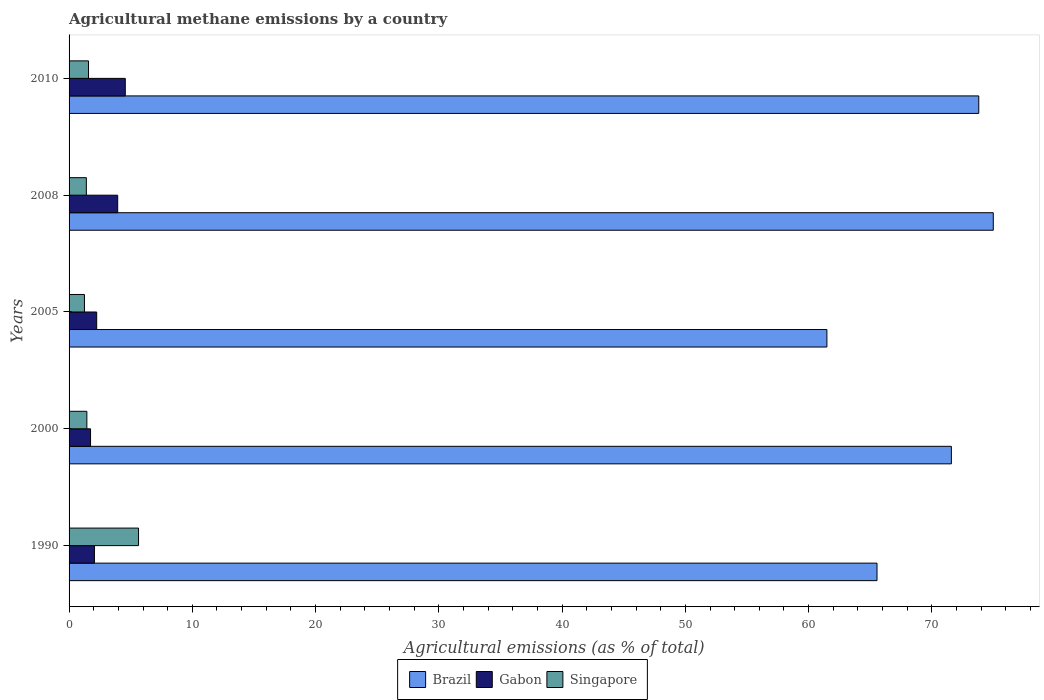How many different coloured bars are there?
Offer a terse response. 3. Are the number of bars per tick equal to the number of legend labels?
Ensure brevity in your answer.  Yes. Are the number of bars on each tick of the Y-axis equal?
Give a very brief answer. Yes. How many bars are there on the 1st tick from the top?
Ensure brevity in your answer.  3. What is the label of the 5th group of bars from the top?
Your answer should be very brief. 1990. What is the amount of agricultural methane emitted in Gabon in 2005?
Offer a very short reply. 2.24. Across all years, what is the maximum amount of agricultural methane emitted in Singapore?
Offer a terse response. 5.63. Across all years, what is the minimum amount of agricultural methane emitted in Brazil?
Make the answer very short. 61.48. In which year was the amount of agricultural methane emitted in Brazil maximum?
Keep it short and to the point. 2008. What is the total amount of agricultural methane emitted in Gabon in the graph?
Offer a terse response. 14.55. What is the difference between the amount of agricultural methane emitted in Gabon in 2008 and that in 2010?
Make the answer very short. -0.62. What is the difference between the amount of agricultural methane emitted in Gabon in 2010 and the amount of agricultural methane emitted in Brazil in 2005?
Your answer should be compact. -56.92. What is the average amount of agricultural methane emitted in Singapore per year?
Offer a very short reply. 2.26. In the year 2010, what is the difference between the amount of agricultural methane emitted in Brazil and amount of agricultural methane emitted in Gabon?
Offer a terse response. 69.24. What is the ratio of the amount of agricultural methane emitted in Brazil in 2008 to that in 2010?
Make the answer very short. 1.02. Is the amount of agricultural methane emitted in Gabon in 2005 less than that in 2008?
Your answer should be very brief. Yes. What is the difference between the highest and the second highest amount of agricultural methane emitted in Singapore?
Offer a very short reply. 4.06. What is the difference between the highest and the lowest amount of agricultural methane emitted in Brazil?
Your answer should be compact. 13.5. Is the sum of the amount of agricultural methane emitted in Singapore in 1990 and 2008 greater than the maximum amount of agricultural methane emitted in Gabon across all years?
Give a very brief answer. Yes. What does the 2nd bar from the top in 2010 represents?
Give a very brief answer. Gabon. Is it the case that in every year, the sum of the amount of agricultural methane emitted in Brazil and amount of agricultural methane emitted in Singapore is greater than the amount of agricultural methane emitted in Gabon?
Your answer should be very brief. Yes. What is the difference between two consecutive major ticks on the X-axis?
Offer a very short reply. 10. Are the values on the major ticks of X-axis written in scientific E-notation?
Keep it short and to the point. No. How many legend labels are there?
Provide a succinct answer. 3. What is the title of the graph?
Make the answer very short. Agricultural methane emissions by a country. Does "Upper middle income" appear as one of the legend labels in the graph?
Offer a very short reply. No. What is the label or title of the X-axis?
Offer a terse response. Agricultural emissions (as % of total). What is the label or title of the Y-axis?
Offer a very short reply. Years. What is the Agricultural emissions (as % of total) in Brazil in 1990?
Provide a succinct answer. 65.55. What is the Agricultural emissions (as % of total) of Gabon in 1990?
Offer a very short reply. 2.06. What is the Agricultural emissions (as % of total) of Singapore in 1990?
Provide a short and direct response. 5.63. What is the Agricultural emissions (as % of total) in Brazil in 2000?
Ensure brevity in your answer.  71.58. What is the Agricultural emissions (as % of total) in Gabon in 2000?
Offer a terse response. 1.74. What is the Agricultural emissions (as % of total) in Singapore in 2000?
Provide a short and direct response. 1.44. What is the Agricultural emissions (as % of total) in Brazil in 2005?
Provide a short and direct response. 61.48. What is the Agricultural emissions (as % of total) in Gabon in 2005?
Provide a succinct answer. 2.24. What is the Agricultural emissions (as % of total) of Singapore in 2005?
Make the answer very short. 1.25. What is the Agricultural emissions (as % of total) of Brazil in 2008?
Your answer should be very brief. 74.98. What is the Agricultural emissions (as % of total) of Gabon in 2008?
Your answer should be very brief. 3.94. What is the Agricultural emissions (as % of total) in Singapore in 2008?
Your answer should be very brief. 1.4. What is the Agricultural emissions (as % of total) of Brazil in 2010?
Offer a very short reply. 73.8. What is the Agricultural emissions (as % of total) of Gabon in 2010?
Ensure brevity in your answer.  4.56. What is the Agricultural emissions (as % of total) in Singapore in 2010?
Make the answer very short. 1.58. Across all years, what is the maximum Agricultural emissions (as % of total) in Brazil?
Provide a succinct answer. 74.98. Across all years, what is the maximum Agricultural emissions (as % of total) of Gabon?
Offer a very short reply. 4.56. Across all years, what is the maximum Agricultural emissions (as % of total) of Singapore?
Provide a succinct answer. 5.63. Across all years, what is the minimum Agricultural emissions (as % of total) in Brazil?
Offer a terse response. 61.48. Across all years, what is the minimum Agricultural emissions (as % of total) of Gabon?
Keep it short and to the point. 1.74. Across all years, what is the minimum Agricultural emissions (as % of total) in Singapore?
Your answer should be compact. 1.25. What is the total Agricultural emissions (as % of total) in Brazil in the graph?
Your answer should be very brief. 347.4. What is the total Agricultural emissions (as % of total) of Gabon in the graph?
Your answer should be compact. 14.55. What is the total Agricultural emissions (as % of total) in Singapore in the graph?
Offer a very short reply. 11.3. What is the difference between the Agricultural emissions (as % of total) of Brazil in 1990 and that in 2000?
Your response must be concise. -6.03. What is the difference between the Agricultural emissions (as % of total) of Gabon in 1990 and that in 2000?
Provide a succinct answer. 0.32. What is the difference between the Agricultural emissions (as % of total) in Singapore in 1990 and that in 2000?
Make the answer very short. 4.19. What is the difference between the Agricultural emissions (as % of total) in Brazil in 1990 and that in 2005?
Keep it short and to the point. 4.07. What is the difference between the Agricultural emissions (as % of total) of Gabon in 1990 and that in 2005?
Give a very brief answer. -0.18. What is the difference between the Agricultural emissions (as % of total) of Singapore in 1990 and that in 2005?
Provide a short and direct response. 4.39. What is the difference between the Agricultural emissions (as % of total) of Brazil in 1990 and that in 2008?
Your answer should be compact. -9.43. What is the difference between the Agricultural emissions (as % of total) in Gabon in 1990 and that in 2008?
Your answer should be compact. -1.89. What is the difference between the Agricultural emissions (as % of total) in Singapore in 1990 and that in 2008?
Provide a short and direct response. 4.23. What is the difference between the Agricultural emissions (as % of total) in Brazil in 1990 and that in 2010?
Give a very brief answer. -8.25. What is the difference between the Agricultural emissions (as % of total) of Gabon in 1990 and that in 2010?
Give a very brief answer. -2.5. What is the difference between the Agricultural emissions (as % of total) in Singapore in 1990 and that in 2010?
Your response must be concise. 4.06. What is the difference between the Agricultural emissions (as % of total) in Brazil in 2000 and that in 2005?
Offer a very short reply. 10.1. What is the difference between the Agricultural emissions (as % of total) of Gabon in 2000 and that in 2005?
Provide a succinct answer. -0.5. What is the difference between the Agricultural emissions (as % of total) in Singapore in 2000 and that in 2005?
Make the answer very short. 0.2. What is the difference between the Agricultural emissions (as % of total) in Brazil in 2000 and that in 2008?
Offer a very short reply. -3.4. What is the difference between the Agricultural emissions (as % of total) of Gabon in 2000 and that in 2008?
Ensure brevity in your answer.  -2.2. What is the difference between the Agricultural emissions (as % of total) of Singapore in 2000 and that in 2008?
Offer a very short reply. 0.04. What is the difference between the Agricultural emissions (as % of total) of Brazil in 2000 and that in 2010?
Keep it short and to the point. -2.22. What is the difference between the Agricultural emissions (as % of total) in Gabon in 2000 and that in 2010?
Your answer should be very brief. -2.82. What is the difference between the Agricultural emissions (as % of total) in Singapore in 2000 and that in 2010?
Make the answer very short. -0.13. What is the difference between the Agricultural emissions (as % of total) in Brazil in 2005 and that in 2008?
Make the answer very short. -13.5. What is the difference between the Agricultural emissions (as % of total) of Gabon in 2005 and that in 2008?
Offer a very short reply. -1.7. What is the difference between the Agricultural emissions (as % of total) of Singapore in 2005 and that in 2008?
Make the answer very short. -0.15. What is the difference between the Agricultural emissions (as % of total) in Brazil in 2005 and that in 2010?
Offer a terse response. -12.32. What is the difference between the Agricultural emissions (as % of total) in Gabon in 2005 and that in 2010?
Provide a succinct answer. -2.32. What is the difference between the Agricultural emissions (as % of total) of Singapore in 2005 and that in 2010?
Keep it short and to the point. -0.33. What is the difference between the Agricultural emissions (as % of total) of Brazil in 2008 and that in 2010?
Your answer should be compact. 1.18. What is the difference between the Agricultural emissions (as % of total) in Gabon in 2008 and that in 2010?
Give a very brief answer. -0.62. What is the difference between the Agricultural emissions (as % of total) in Singapore in 2008 and that in 2010?
Ensure brevity in your answer.  -0.18. What is the difference between the Agricultural emissions (as % of total) of Brazil in 1990 and the Agricultural emissions (as % of total) of Gabon in 2000?
Give a very brief answer. 63.81. What is the difference between the Agricultural emissions (as % of total) of Brazil in 1990 and the Agricultural emissions (as % of total) of Singapore in 2000?
Offer a terse response. 64.11. What is the difference between the Agricultural emissions (as % of total) of Gabon in 1990 and the Agricultural emissions (as % of total) of Singapore in 2000?
Offer a terse response. 0.62. What is the difference between the Agricultural emissions (as % of total) in Brazil in 1990 and the Agricultural emissions (as % of total) in Gabon in 2005?
Make the answer very short. 63.31. What is the difference between the Agricultural emissions (as % of total) in Brazil in 1990 and the Agricultural emissions (as % of total) in Singapore in 2005?
Offer a very short reply. 64.3. What is the difference between the Agricultural emissions (as % of total) in Gabon in 1990 and the Agricultural emissions (as % of total) in Singapore in 2005?
Make the answer very short. 0.81. What is the difference between the Agricultural emissions (as % of total) in Brazil in 1990 and the Agricultural emissions (as % of total) in Gabon in 2008?
Offer a very short reply. 61.61. What is the difference between the Agricultural emissions (as % of total) in Brazil in 1990 and the Agricultural emissions (as % of total) in Singapore in 2008?
Your answer should be compact. 64.15. What is the difference between the Agricultural emissions (as % of total) in Gabon in 1990 and the Agricultural emissions (as % of total) in Singapore in 2008?
Provide a succinct answer. 0.66. What is the difference between the Agricultural emissions (as % of total) of Brazil in 1990 and the Agricultural emissions (as % of total) of Gabon in 2010?
Keep it short and to the point. 60.99. What is the difference between the Agricultural emissions (as % of total) in Brazil in 1990 and the Agricultural emissions (as % of total) in Singapore in 2010?
Provide a succinct answer. 63.97. What is the difference between the Agricultural emissions (as % of total) of Gabon in 1990 and the Agricultural emissions (as % of total) of Singapore in 2010?
Your answer should be compact. 0.48. What is the difference between the Agricultural emissions (as % of total) of Brazil in 2000 and the Agricultural emissions (as % of total) of Gabon in 2005?
Give a very brief answer. 69.34. What is the difference between the Agricultural emissions (as % of total) of Brazil in 2000 and the Agricultural emissions (as % of total) of Singapore in 2005?
Your response must be concise. 70.33. What is the difference between the Agricultural emissions (as % of total) of Gabon in 2000 and the Agricultural emissions (as % of total) of Singapore in 2005?
Ensure brevity in your answer.  0.49. What is the difference between the Agricultural emissions (as % of total) in Brazil in 2000 and the Agricultural emissions (as % of total) in Gabon in 2008?
Offer a very short reply. 67.64. What is the difference between the Agricultural emissions (as % of total) in Brazil in 2000 and the Agricultural emissions (as % of total) in Singapore in 2008?
Provide a succinct answer. 70.18. What is the difference between the Agricultural emissions (as % of total) in Gabon in 2000 and the Agricultural emissions (as % of total) in Singapore in 2008?
Your answer should be very brief. 0.34. What is the difference between the Agricultural emissions (as % of total) of Brazil in 2000 and the Agricultural emissions (as % of total) of Gabon in 2010?
Offer a terse response. 67.02. What is the difference between the Agricultural emissions (as % of total) in Brazil in 2000 and the Agricultural emissions (as % of total) in Singapore in 2010?
Keep it short and to the point. 70. What is the difference between the Agricultural emissions (as % of total) of Gabon in 2000 and the Agricultural emissions (as % of total) of Singapore in 2010?
Your answer should be compact. 0.16. What is the difference between the Agricultural emissions (as % of total) of Brazil in 2005 and the Agricultural emissions (as % of total) of Gabon in 2008?
Provide a succinct answer. 57.54. What is the difference between the Agricultural emissions (as % of total) in Brazil in 2005 and the Agricultural emissions (as % of total) in Singapore in 2008?
Your answer should be very brief. 60.08. What is the difference between the Agricultural emissions (as % of total) in Gabon in 2005 and the Agricultural emissions (as % of total) in Singapore in 2008?
Provide a succinct answer. 0.84. What is the difference between the Agricultural emissions (as % of total) in Brazil in 2005 and the Agricultural emissions (as % of total) in Gabon in 2010?
Offer a terse response. 56.92. What is the difference between the Agricultural emissions (as % of total) in Brazil in 2005 and the Agricultural emissions (as % of total) in Singapore in 2010?
Offer a very short reply. 59.91. What is the difference between the Agricultural emissions (as % of total) of Gabon in 2005 and the Agricultural emissions (as % of total) of Singapore in 2010?
Provide a short and direct response. 0.66. What is the difference between the Agricultural emissions (as % of total) in Brazil in 2008 and the Agricultural emissions (as % of total) in Gabon in 2010?
Your answer should be compact. 70.42. What is the difference between the Agricultural emissions (as % of total) of Brazil in 2008 and the Agricultural emissions (as % of total) of Singapore in 2010?
Ensure brevity in your answer.  73.4. What is the difference between the Agricultural emissions (as % of total) in Gabon in 2008 and the Agricultural emissions (as % of total) in Singapore in 2010?
Give a very brief answer. 2.37. What is the average Agricultural emissions (as % of total) in Brazil per year?
Your response must be concise. 69.48. What is the average Agricultural emissions (as % of total) of Gabon per year?
Keep it short and to the point. 2.91. What is the average Agricultural emissions (as % of total) in Singapore per year?
Make the answer very short. 2.26. In the year 1990, what is the difference between the Agricultural emissions (as % of total) of Brazil and Agricultural emissions (as % of total) of Gabon?
Your answer should be very brief. 63.49. In the year 1990, what is the difference between the Agricultural emissions (as % of total) of Brazil and Agricultural emissions (as % of total) of Singapore?
Make the answer very short. 59.91. In the year 1990, what is the difference between the Agricultural emissions (as % of total) in Gabon and Agricultural emissions (as % of total) in Singapore?
Keep it short and to the point. -3.58. In the year 2000, what is the difference between the Agricultural emissions (as % of total) in Brazil and Agricultural emissions (as % of total) in Gabon?
Offer a very short reply. 69.84. In the year 2000, what is the difference between the Agricultural emissions (as % of total) in Brazil and Agricultural emissions (as % of total) in Singapore?
Give a very brief answer. 70.14. In the year 2000, what is the difference between the Agricultural emissions (as % of total) in Gabon and Agricultural emissions (as % of total) in Singapore?
Your answer should be very brief. 0.3. In the year 2005, what is the difference between the Agricultural emissions (as % of total) in Brazil and Agricultural emissions (as % of total) in Gabon?
Your response must be concise. 59.24. In the year 2005, what is the difference between the Agricultural emissions (as % of total) in Brazil and Agricultural emissions (as % of total) in Singapore?
Ensure brevity in your answer.  60.24. In the year 2005, what is the difference between the Agricultural emissions (as % of total) of Gabon and Agricultural emissions (as % of total) of Singapore?
Make the answer very short. 0.99. In the year 2008, what is the difference between the Agricultural emissions (as % of total) of Brazil and Agricultural emissions (as % of total) of Gabon?
Your response must be concise. 71.04. In the year 2008, what is the difference between the Agricultural emissions (as % of total) in Brazil and Agricultural emissions (as % of total) in Singapore?
Provide a short and direct response. 73.58. In the year 2008, what is the difference between the Agricultural emissions (as % of total) of Gabon and Agricultural emissions (as % of total) of Singapore?
Keep it short and to the point. 2.54. In the year 2010, what is the difference between the Agricultural emissions (as % of total) in Brazil and Agricultural emissions (as % of total) in Gabon?
Offer a terse response. 69.24. In the year 2010, what is the difference between the Agricultural emissions (as % of total) of Brazil and Agricultural emissions (as % of total) of Singapore?
Ensure brevity in your answer.  72.23. In the year 2010, what is the difference between the Agricultural emissions (as % of total) of Gabon and Agricultural emissions (as % of total) of Singapore?
Ensure brevity in your answer.  2.98. What is the ratio of the Agricultural emissions (as % of total) in Brazil in 1990 to that in 2000?
Make the answer very short. 0.92. What is the ratio of the Agricultural emissions (as % of total) in Gabon in 1990 to that in 2000?
Offer a very short reply. 1.18. What is the ratio of the Agricultural emissions (as % of total) of Singapore in 1990 to that in 2000?
Ensure brevity in your answer.  3.9. What is the ratio of the Agricultural emissions (as % of total) in Brazil in 1990 to that in 2005?
Offer a terse response. 1.07. What is the ratio of the Agricultural emissions (as % of total) of Gabon in 1990 to that in 2005?
Offer a very short reply. 0.92. What is the ratio of the Agricultural emissions (as % of total) of Singapore in 1990 to that in 2005?
Your answer should be very brief. 4.52. What is the ratio of the Agricultural emissions (as % of total) of Brazil in 1990 to that in 2008?
Your response must be concise. 0.87. What is the ratio of the Agricultural emissions (as % of total) in Gabon in 1990 to that in 2008?
Provide a succinct answer. 0.52. What is the ratio of the Agricultural emissions (as % of total) of Singapore in 1990 to that in 2008?
Ensure brevity in your answer.  4.02. What is the ratio of the Agricultural emissions (as % of total) in Brazil in 1990 to that in 2010?
Make the answer very short. 0.89. What is the ratio of the Agricultural emissions (as % of total) of Gabon in 1990 to that in 2010?
Your response must be concise. 0.45. What is the ratio of the Agricultural emissions (as % of total) in Singapore in 1990 to that in 2010?
Your answer should be compact. 3.57. What is the ratio of the Agricultural emissions (as % of total) in Brazil in 2000 to that in 2005?
Provide a succinct answer. 1.16. What is the ratio of the Agricultural emissions (as % of total) of Gabon in 2000 to that in 2005?
Keep it short and to the point. 0.78. What is the ratio of the Agricultural emissions (as % of total) in Singapore in 2000 to that in 2005?
Your response must be concise. 1.16. What is the ratio of the Agricultural emissions (as % of total) in Brazil in 2000 to that in 2008?
Provide a short and direct response. 0.95. What is the ratio of the Agricultural emissions (as % of total) in Gabon in 2000 to that in 2008?
Make the answer very short. 0.44. What is the ratio of the Agricultural emissions (as % of total) of Singapore in 2000 to that in 2008?
Offer a terse response. 1.03. What is the ratio of the Agricultural emissions (as % of total) in Brazil in 2000 to that in 2010?
Provide a short and direct response. 0.97. What is the ratio of the Agricultural emissions (as % of total) in Gabon in 2000 to that in 2010?
Offer a terse response. 0.38. What is the ratio of the Agricultural emissions (as % of total) in Singapore in 2000 to that in 2010?
Provide a succinct answer. 0.91. What is the ratio of the Agricultural emissions (as % of total) in Brazil in 2005 to that in 2008?
Offer a terse response. 0.82. What is the ratio of the Agricultural emissions (as % of total) in Gabon in 2005 to that in 2008?
Your answer should be very brief. 0.57. What is the ratio of the Agricultural emissions (as % of total) in Singapore in 2005 to that in 2008?
Ensure brevity in your answer.  0.89. What is the ratio of the Agricultural emissions (as % of total) of Brazil in 2005 to that in 2010?
Make the answer very short. 0.83. What is the ratio of the Agricultural emissions (as % of total) in Gabon in 2005 to that in 2010?
Offer a terse response. 0.49. What is the ratio of the Agricultural emissions (as % of total) in Singapore in 2005 to that in 2010?
Your answer should be very brief. 0.79. What is the ratio of the Agricultural emissions (as % of total) of Brazil in 2008 to that in 2010?
Ensure brevity in your answer.  1.02. What is the ratio of the Agricultural emissions (as % of total) of Gabon in 2008 to that in 2010?
Provide a short and direct response. 0.86. What is the ratio of the Agricultural emissions (as % of total) in Singapore in 2008 to that in 2010?
Provide a succinct answer. 0.89. What is the difference between the highest and the second highest Agricultural emissions (as % of total) in Brazil?
Give a very brief answer. 1.18. What is the difference between the highest and the second highest Agricultural emissions (as % of total) of Gabon?
Keep it short and to the point. 0.62. What is the difference between the highest and the second highest Agricultural emissions (as % of total) in Singapore?
Offer a terse response. 4.06. What is the difference between the highest and the lowest Agricultural emissions (as % of total) of Brazil?
Make the answer very short. 13.5. What is the difference between the highest and the lowest Agricultural emissions (as % of total) of Gabon?
Keep it short and to the point. 2.82. What is the difference between the highest and the lowest Agricultural emissions (as % of total) in Singapore?
Offer a terse response. 4.39. 